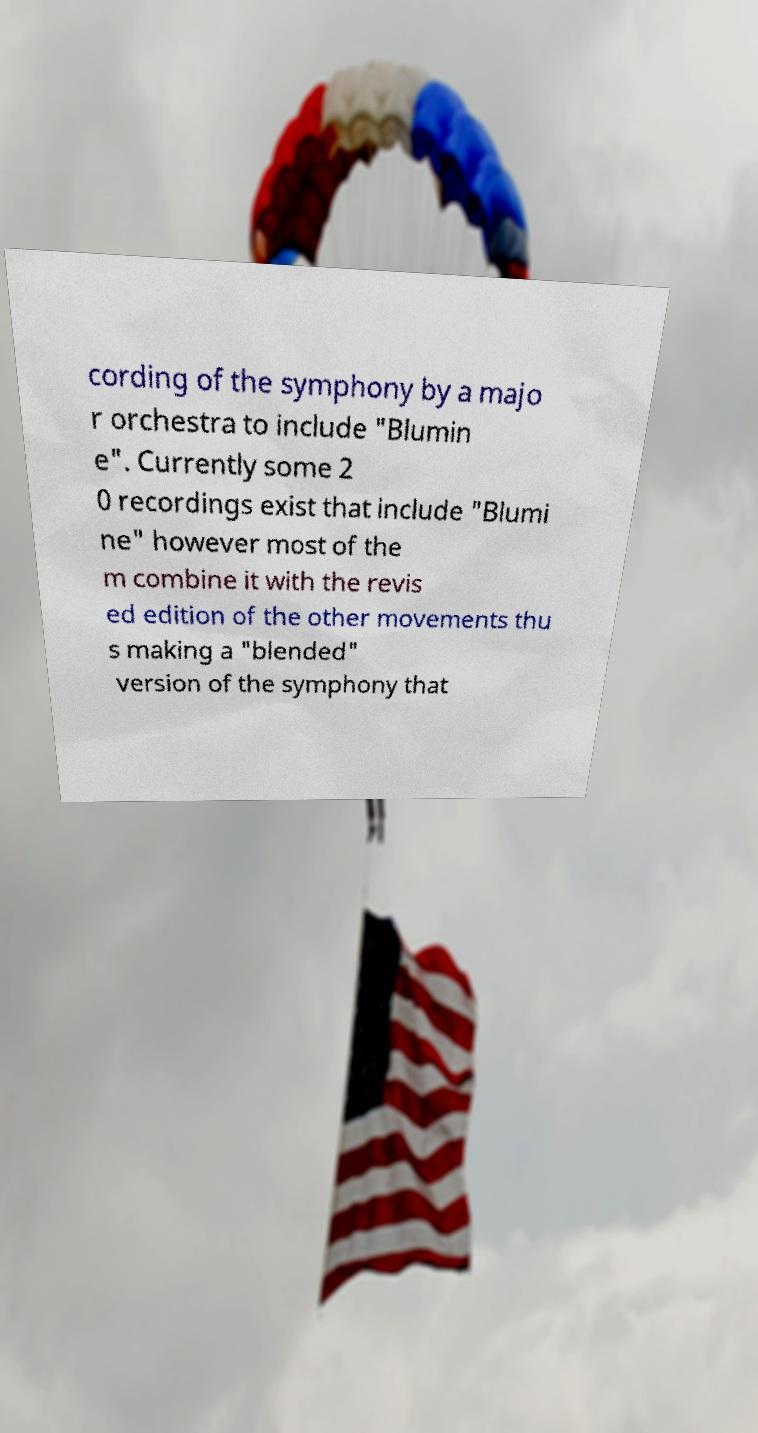What messages or text are displayed in this image? I need them in a readable, typed format. cording of the symphony by a majo r orchestra to include "Blumin e". Currently some 2 0 recordings exist that include "Blumi ne" however most of the m combine it with the revis ed edition of the other movements thu s making a "blended" version of the symphony that 